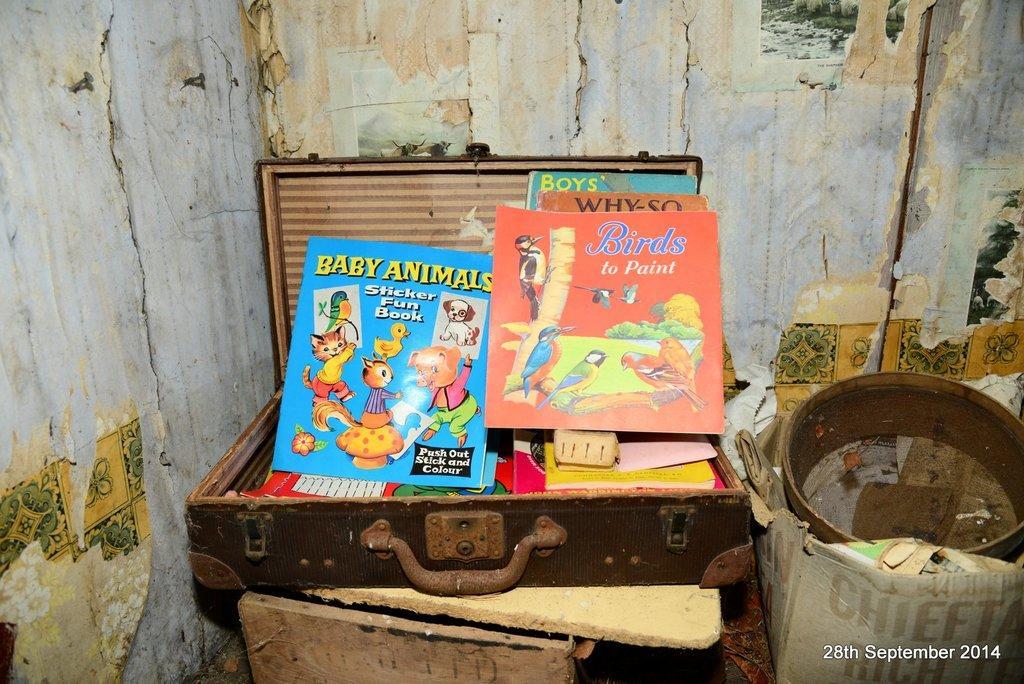Can you describe this image briefly? In this picture we can see some colorful objects in the suitcase. We can see the wooden objects. We can see a few objects in a box. There are posters and some designs visible on the wall. 